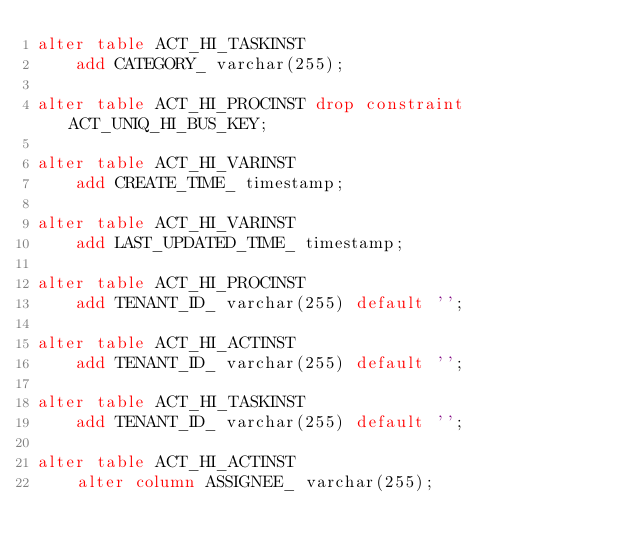<code> <loc_0><loc_0><loc_500><loc_500><_SQL_>alter table ACT_HI_TASKINST
    add CATEGORY_ varchar(255);
    
alter table ACT_HI_PROCINST drop constraint ACT_UNIQ_HI_BUS_KEY;    
    
alter table ACT_HI_VARINST
    add CREATE_TIME_ timestamp; 
    
alter table ACT_HI_VARINST
    add LAST_UPDATED_TIME_ timestamp; 
    
alter table ACT_HI_PROCINST
    add TENANT_ID_ varchar(255) default ''; 
       
alter table ACT_HI_ACTINST
    add TENANT_ID_ varchar(255) default ''; 
    
alter table ACT_HI_TASKINST
    add TENANT_ID_ varchar(255) default '';    
    
alter table ACT_HI_ACTINST
    alter column ASSIGNEE_ varchar(255);</code> 